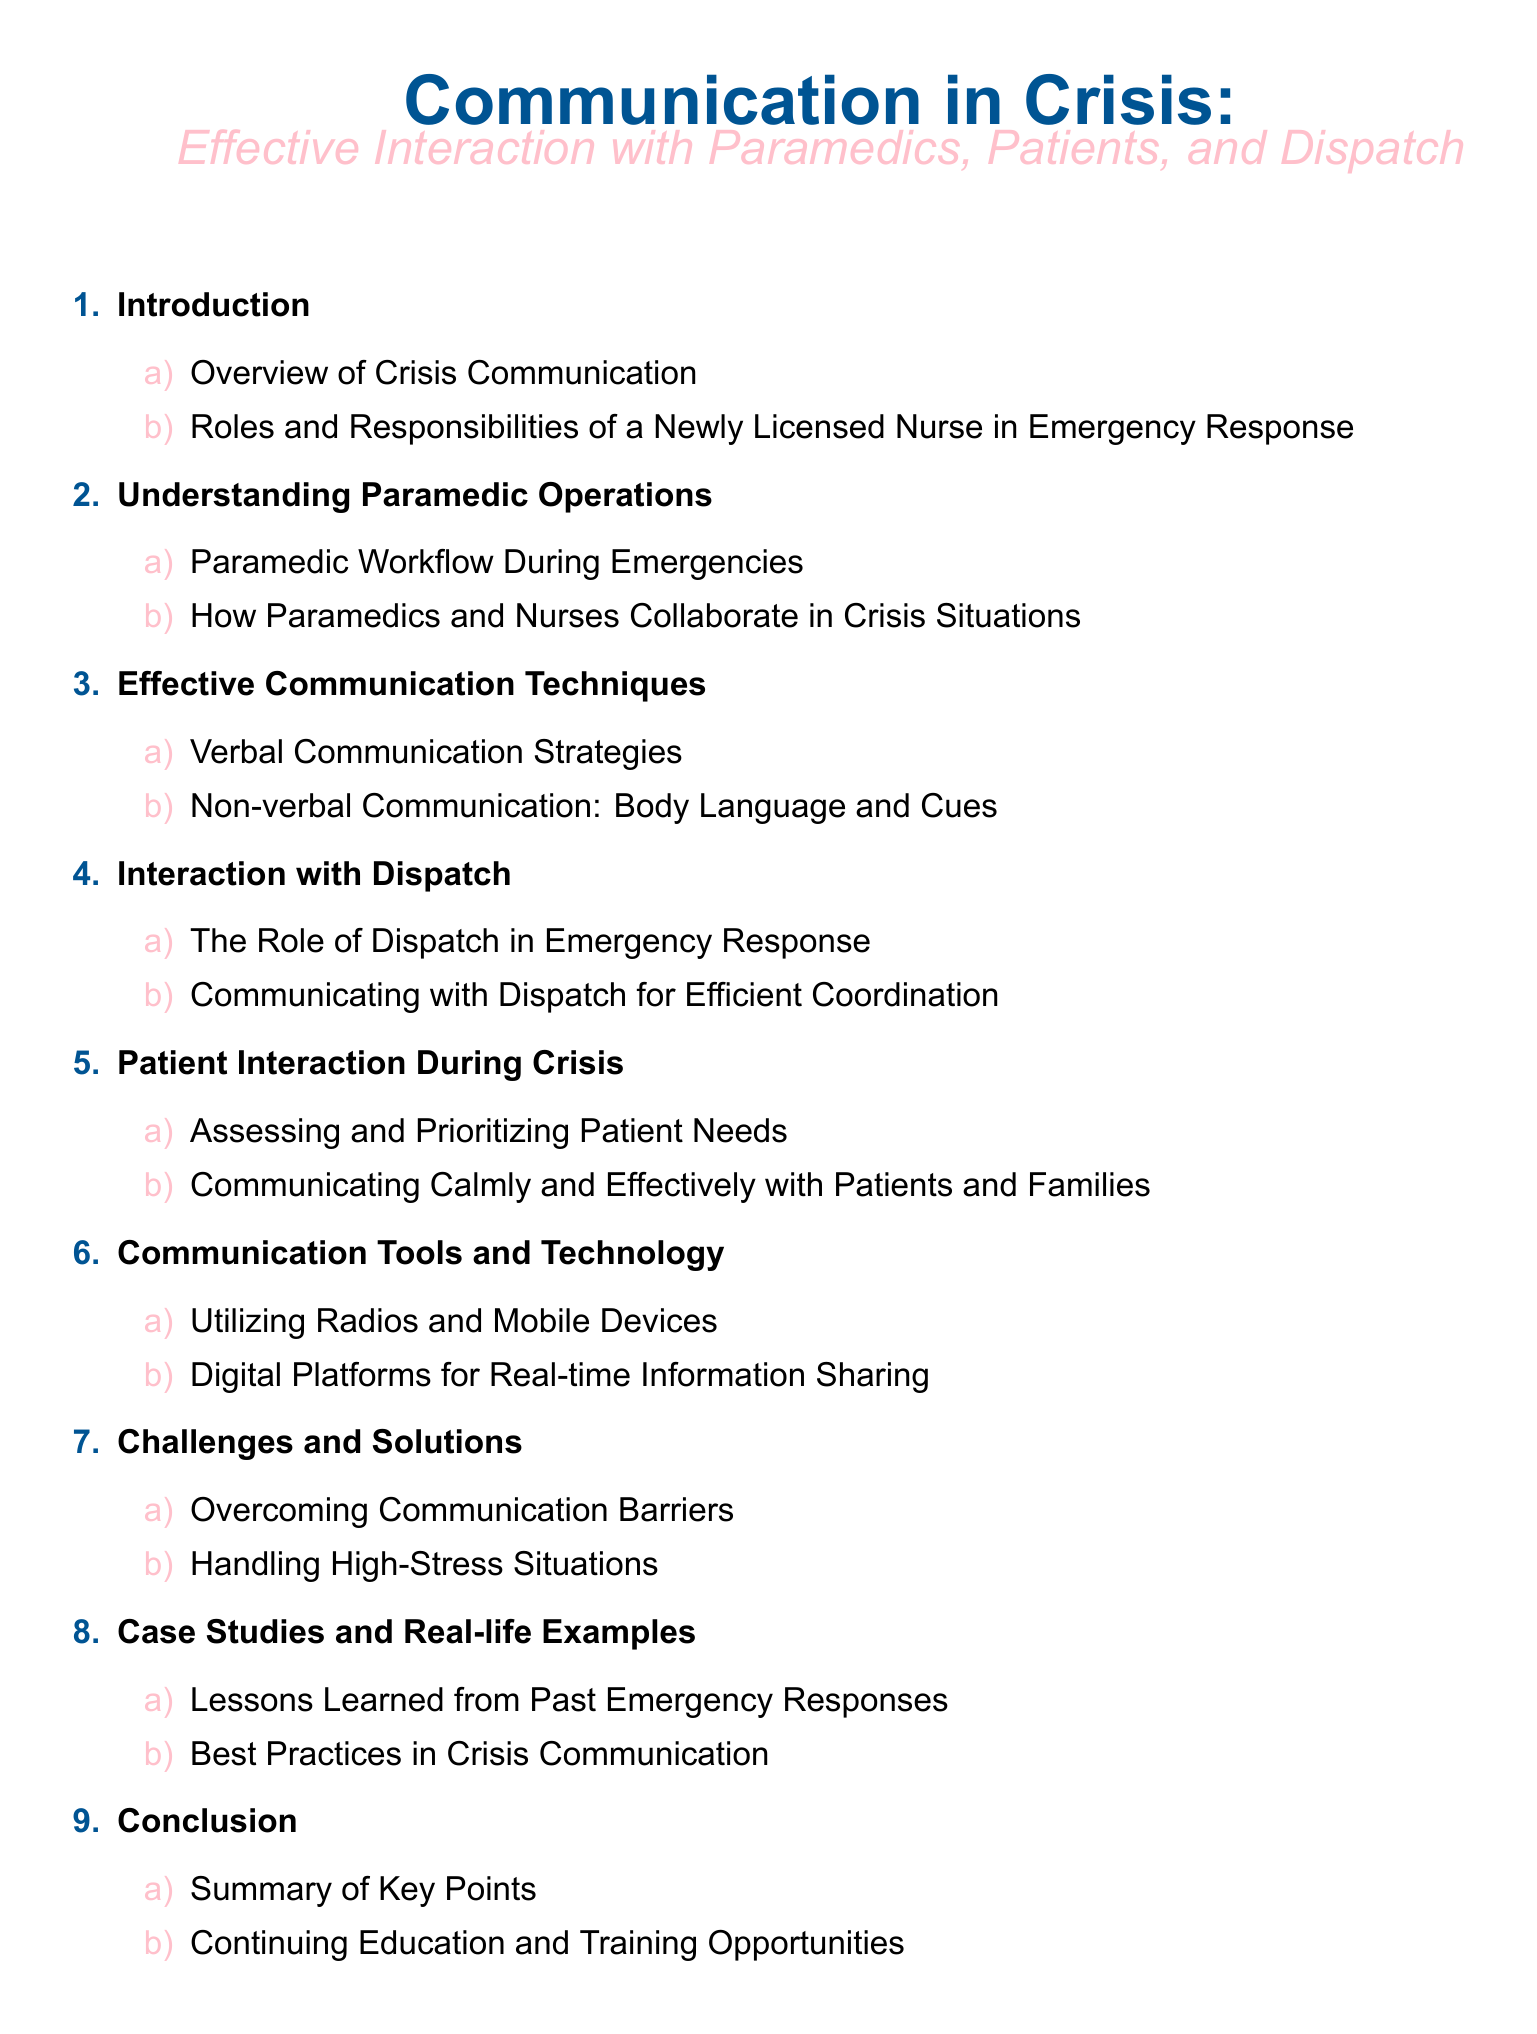What is the title of the document? The title of the document is prominently displayed at the top, indicating the subject matter of the content.
Answer: Communication in Crisis: Effective Interaction with Paramedics, Patients, and Dispatch How many main sections are in the Table of Contents? Each numbered item in the list represents a main section of the document, counted to determine the total.
Answer: 9 What role does a newly licensed nurse have in emergency response? The document outlines specific responsibilities for the nurse, categorized under one of the sections.
Answer: Roles and Responsibilities of a Newly Licensed Nurse in Emergency Response What is the focus of section 3 in the document? Each section is titled, and section 3 is designated to discuss communication methods, which can be inferred from its title.
Answer: Effective Communication Techniques How do paramedics and nurses collaborate? This is addressed in one of the subsections of the document, highlighting the partnership in emergency situations.
Answer: How Paramedics and Nurses Collaborate in Crisis Situations What is one challenge mentioned in the document regarding communication? The challenges are specifically listed, and this question requires identifying one among them.
Answer: Overcoming Communication Barriers What tools are discussed for communication in crisis situations? The document includes tools that enhance communication effectiveness, stated in the relevant section.
Answer: Utilizing Radios and Mobile Devices How many case studies are included? The subsection provides an insight into the contents of the section focusing on real-life examples.
Answer: 2 What is the final section titled in the Table of Contents? The conclusion section typically summarizes the document and is listed at the bottom of the Table of Contents.
Answer: Conclusion 